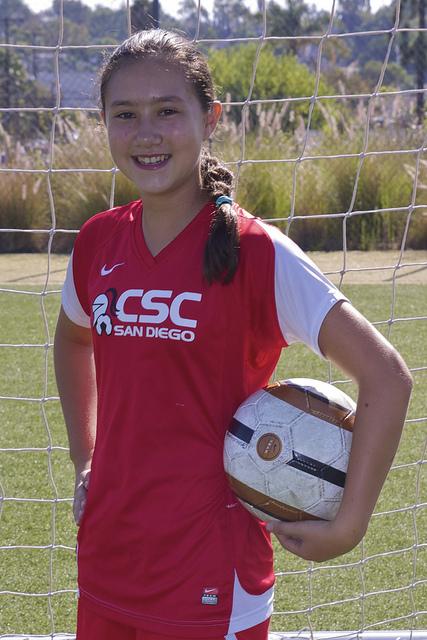What sport is this child playing?
Give a very brief answer. Soccer. Is this girl an adult?
Answer briefly. No. What is the girl holding?
Write a very short answer. Soccer ball. What city does she live in?
Keep it brief. San diego. 